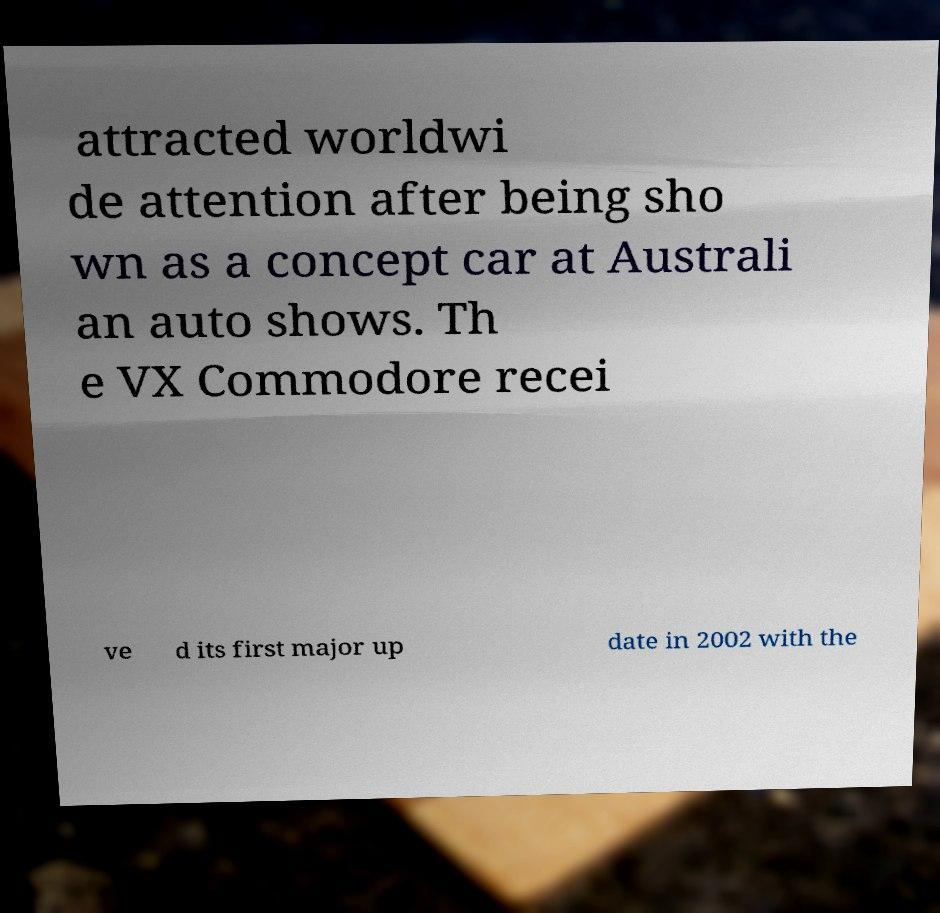What messages or text are displayed in this image? I need them in a readable, typed format. attracted worldwi de attention after being sho wn as a concept car at Australi an auto shows. Th e VX Commodore recei ve d its first major up date in 2002 with the 